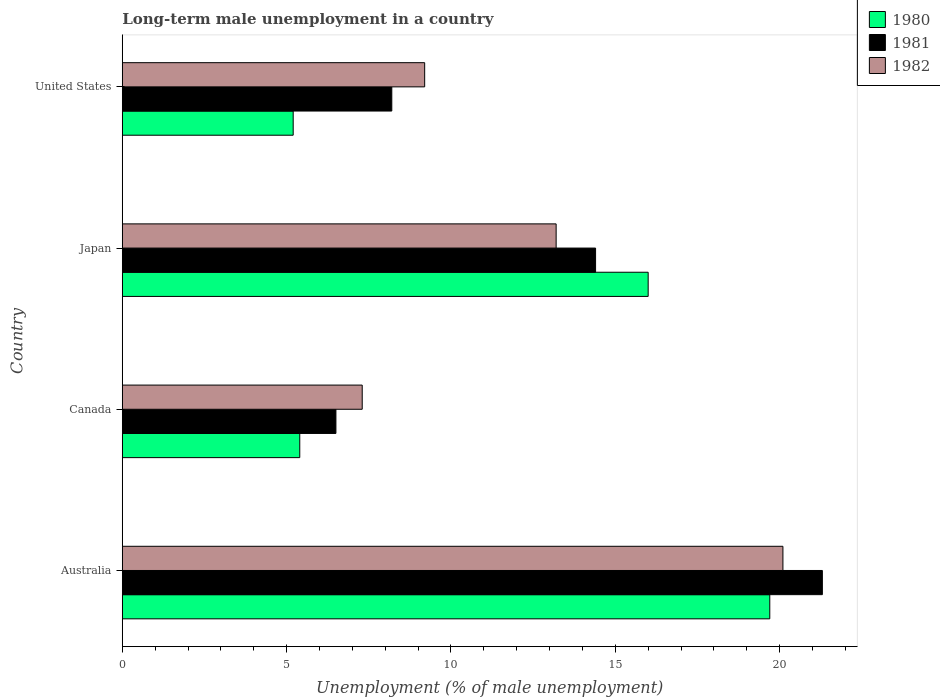How many different coloured bars are there?
Your response must be concise. 3. Are the number of bars per tick equal to the number of legend labels?
Your answer should be compact. Yes. How many bars are there on the 4th tick from the top?
Your response must be concise. 3. In how many cases, is the number of bars for a given country not equal to the number of legend labels?
Make the answer very short. 0. Across all countries, what is the maximum percentage of long-term unemployed male population in 1982?
Ensure brevity in your answer.  20.1. In which country was the percentage of long-term unemployed male population in 1982 maximum?
Offer a very short reply. Australia. In which country was the percentage of long-term unemployed male population in 1981 minimum?
Make the answer very short. Canada. What is the total percentage of long-term unemployed male population in 1982 in the graph?
Your response must be concise. 49.8. What is the difference between the percentage of long-term unemployed male population in 1981 in Australia and that in Canada?
Make the answer very short. 14.8. What is the difference between the percentage of long-term unemployed male population in 1981 in Japan and the percentage of long-term unemployed male population in 1982 in Canada?
Provide a succinct answer. 7.1. What is the average percentage of long-term unemployed male population in 1982 per country?
Your response must be concise. 12.45. What is the difference between the percentage of long-term unemployed male population in 1981 and percentage of long-term unemployed male population in 1980 in Canada?
Keep it short and to the point. 1.1. In how many countries, is the percentage of long-term unemployed male population in 1981 greater than 16 %?
Offer a terse response. 1. What is the ratio of the percentage of long-term unemployed male population in 1981 in Australia to that in Canada?
Give a very brief answer. 3.28. Is the difference between the percentage of long-term unemployed male population in 1981 in Australia and United States greater than the difference between the percentage of long-term unemployed male population in 1980 in Australia and United States?
Your response must be concise. No. What is the difference between the highest and the second highest percentage of long-term unemployed male population in 1980?
Provide a succinct answer. 3.7. What is the difference between the highest and the lowest percentage of long-term unemployed male population in 1980?
Give a very brief answer. 14.5. Is the sum of the percentage of long-term unemployed male population in 1981 in Australia and United States greater than the maximum percentage of long-term unemployed male population in 1982 across all countries?
Keep it short and to the point. Yes. What does the 3rd bar from the top in Canada represents?
Your response must be concise. 1980. What does the 2nd bar from the bottom in Canada represents?
Provide a short and direct response. 1981. Is it the case that in every country, the sum of the percentage of long-term unemployed male population in 1980 and percentage of long-term unemployed male population in 1981 is greater than the percentage of long-term unemployed male population in 1982?
Offer a very short reply. Yes. What is the difference between two consecutive major ticks on the X-axis?
Make the answer very short. 5. Are the values on the major ticks of X-axis written in scientific E-notation?
Provide a succinct answer. No. How many legend labels are there?
Your answer should be compact. 3. What is the title of the graph?
Provide a succinct answer. Long-term male unemployment in a country. What is the label or title of the X-axis?
Provide a succinct answer. Unemployment (% of male unemployment). What is the Unemployment (% of male unemployment) in 1980 in Australia?
Your response must be concise. 19.7. What is the Unemployment (% of male unemployment) in 1981 in Australia?
Your answer should be very brief. 21.3. What is the Unemployment (% of male unemployment) of 1982 in Australia?
Offer a terse response. 20.1. What is the Unemployment (% of male unemployment) of 1980 in Canada?
Provide a short and direct response. 5.4. What is the Unemployment (% of male unemployment) in 1982 in Canada?
Offer a terse response. 7.3. What is the Unemployment (% of male unemployment) in 1981 in Japan?
Your response must be concise. 14.4. What is the Unemployment (% of male unemployment) in 1982 in Japan?
Provide a succinct answer. 13.2. What is the Unemployment (% of male unemployment) in 1980 in United States?
Your response must be concise. 5.2. What is the Unemployment (% of male unemployment) of 1981 in United States?
Your answer should be very brief. 8.2. What is the Unemployment (% of male unemployment) in 1982 in United States?
Ensure brevity in your answer.  9.2. Across all countries, what is the maximum Unemployment (% of male unemployment) of 1980?
Make the answer very short. 19.7. Across all countries, what is the maximum Unemployment (% of male unemployment) in 1981?
Give a very brief answer. 21.3. Across all countries, what is the maximum Unemployment (% of male unemployment) of 1982?
Provide a succinct answer. 20.1. Across all countries, what is the minimum Unemployment (% of male unemployment) of 1980?
Your answer should be very brief. 5.2. Across all countries, what is the minimum Unemployment (% of male unemployment) in 1981?
Offer a terse response. 6.5. Across all countries, what is the minimum Unemployment (% of male unemployment) of 1982?
Give a very brief answer. 7.3. What is the total Unemployment (% of male unemployment) of 1980 in the graph?
Offer a terse response. 46.3. What is the total Unemployment (% of male unemployment) in 1981 in the graph?
Offer a terse response. 50.4. What is the total Unemployment (% of male unemployment) of 1982 in the graph?
Your response must be concise. 49.8. What is the difference between the Unemployment (% of male unemployment) in 1980 in Australia and that in Canada?
Keep it short and to the point. 14.3. What is the difference between the Unemployment (% of male unemployment) in 1982 in Australia and that in Canada?
Your answer should be very brief. 12.8. What is the difference between the Unemployment (% of male unemployment) in 1982 in Australia and that in Japan?
Give a very brief answer. 6.9. What is the difference between the Unemployment (% of male unemployment) in 1980 in Australia and that in United States?
Your answer should be very brief. 14.5. What is the difference between the Unemployment (% of male unemployment) in 1982 in Australia and that in United States?
Make the answer very short. 10.9. What is the difference between the Unemployment (% of male unemployment) in 1981 in Canada and that in Japan?
Your response must be concise. -7.9. What is the difference between the Unemployment (% of male unemployment) in 1982 in Canada and that in Japan?
Your response must be concise. -5.9. What is the difference between the Unemployment (% of male unemployment) of 1981 in Canada and that in United States?
Your response must be concise. -1.7. What is the difference between the Unemployment (% of male unemployment) in 1980 in Japan and that in United States?
Your answer should be compact. 10.8. What is the difference between the Unemployment (% of male unemployment) in 1982 in Japan and that in United States?
Provide a short and direct response. 4. What is the difference between the Unemployment (% of male unemployment) of 1981 in Australia and the Unemployment (% of male unemployment) of 1982 in Canada?
Your response must be concise. 14. What is the difference between the Unemployment (% of male unemployment) in 1980 in Australia and the Unemployment (% of male unemployment) in 1981 in Japan?
Offer a very short reply. 5.3. What is the difference between the Unemployment (% of male unemployment) in 1980 in Australia and the Unemployment (% of male unemployment) in 1982 in Japan?
Your response must be concise. 6.5. What is the difference between the Unemployment (% of male unemployment) of 1981 in Australia and the Unemployment (% of male unemployment) of 1982 in Japan?
Offer a very short reply. 8.1. What is the difference between the Unemployment (% of male unemployment) of 1980 in Canada and the Unemployment (% of male unemployment) of 1981 in Japan?
Keep it short and to the point. -9. What is the difference between the Unemployment (% of male unemployment) in 1980 in Canada and the Unemployment (% of male unemployment) in 1982 in Japan?
Offer a terse response. -7.8. What is the difference between the Unemployment (% of male unemployment) of 1981 in Canada and the Unemployment (% of male unemployment) of 1982 in Japan?
Ensure brevity in your answer.  -6.7. What is the difference between the Unemployment (% of male unemployment) in 1980 in Canada and the Unemployment (% of male unemployment) in 1981 in United States?
Your answer should be very brief. -2.8. What is the average Unemployment (% of male unemployment) in 1980 per country?
Ensure brevity in your answer.  11.57. What is the average Unemployment (% of male unemployment) in 1982 per country?
Ensure brevity in your answer.  12.45. What is the difference between the Unemployment (% of male unemployment) in 1980 and Unemployment (% of male unemployment) in 1982 in Australia?
Provide a short and direct response. -0.4. What is the difference between the Unemployment (% of male unemployment) in 1980 and Unemployment (% of male unemployment) in 1981 in Canada?
Make the answer very short. -1.1. What is the difference between the Unemployment (% of male unemployment) of 1980 and Unemployment (% of male unemployment) of 1981 in United States?
Your answer should be very brief. -3. What is the difference between the Unemployment (% of male unemployment) of 1981 and Unemployment (% of male unemployment) of 1982 in United States?
Your answer should be very brief. -1. What is the ratio of the Unemployment (% of male unemployment) in 1980 in Australia to that in Canada?
Ensure brevity in your answer.  3.65. What is the ratio of the Unemployment (% of male unemployment) in 1981 in Australia to that in Canada?
Make the answer very short. 3.28. What is the ratio of the Unemployment (% of male unemployment) of 1982 in Australia to that in Canada?
Offer a very short reply. 2.75. What is the ratio of the Unemployment (% of male unemployment) of 1980 in Australia to that in Japan?
Your response must be concise. 1.23. What is the ratio of the Unemployment (% of male unemployment) of 1981 in Australia to that in Japan?
Your answer should be very brief. 1.48. What is the ratio of the Unemployment (% of male unemployment) of 1982 in Australia to that in Japan?
Provide a short and direct response. 1.52. What is the ratio of the Unemployment (% of male unemployment) of 1980 in Australia to that in United States?
Offer a very short reply. 3.79. What is the ratio of the Unemployment (% of male unemployment) of 1981 in Australia to that in United States?
Your response must be concise. 2.6. What is the ratio of the Unemployment (% of male unemployment) in 1982 in Australia to that in United States?
Ensure brevity in your answer.  2.18. What is the ratio of the Unemployment (% of male unemployment) in 1980 in Canada to that in Japan?
Offer a very short reply. 0.34. What is the ratio of the Unemployment (% of male unemployment) in 1981 in Canada to that in Japan?
Provide a succinct answer. 0.45. What is the ratio of the Unemployment (% of male unemployment) in 1982 in Canada to that in Japan?
Your answer should be compact. 0.55. What is the ratio of the Unemployment (% of male unemployment) in 1981 in Canada to that in United States?
Offer a very short reply. 0.79. What is the ratio of the Unemployment (% of male unemployment) of 1982 in Canada to that in United States?
Provide a short and direct response. 0.79. What is the ratio of the Unemployment (% of male unemployment) in 1980 in Japan to that in United States?
Ensure brevity in your answer.  3.08. What is the ratio of the Unemployment (% of male unemployment) of 1981 in Japan to that in United States?
Your answer should be compact. 1.76. What is the ratio of the Unemployment (% of male unemployment) in 1982 in Japan to that in United States?
Make the answer very short. 1.43. What is the difference between the highest and the second highest Unemployment (% of male unemployment) of 1981?
Offer a very short reply. 6.9. What is the difference between the highest and the second highest Unemployment (% of male unemployment) in 1982?
Keep it short and to the point. 6.9. What is the difference between the highest and the lowest Unemployment (% of male unemployment) of 1982?
Your answer should be very brief. 12.8. 